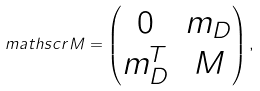<formula> <loc_0><loc_0><loc_500><loc_500>\ m a t h s c r { M } = \left ( \begin{matrix} 0 & m _ { D } \\ m _ { D } ^ { T } & M \end{matrix} \right ) ,</formula> 